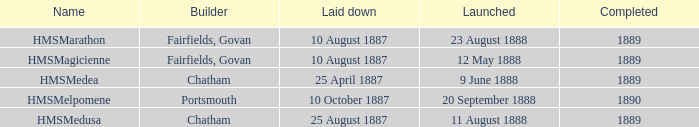What boat was laid down on 25 april 1887? HMSMedea. 